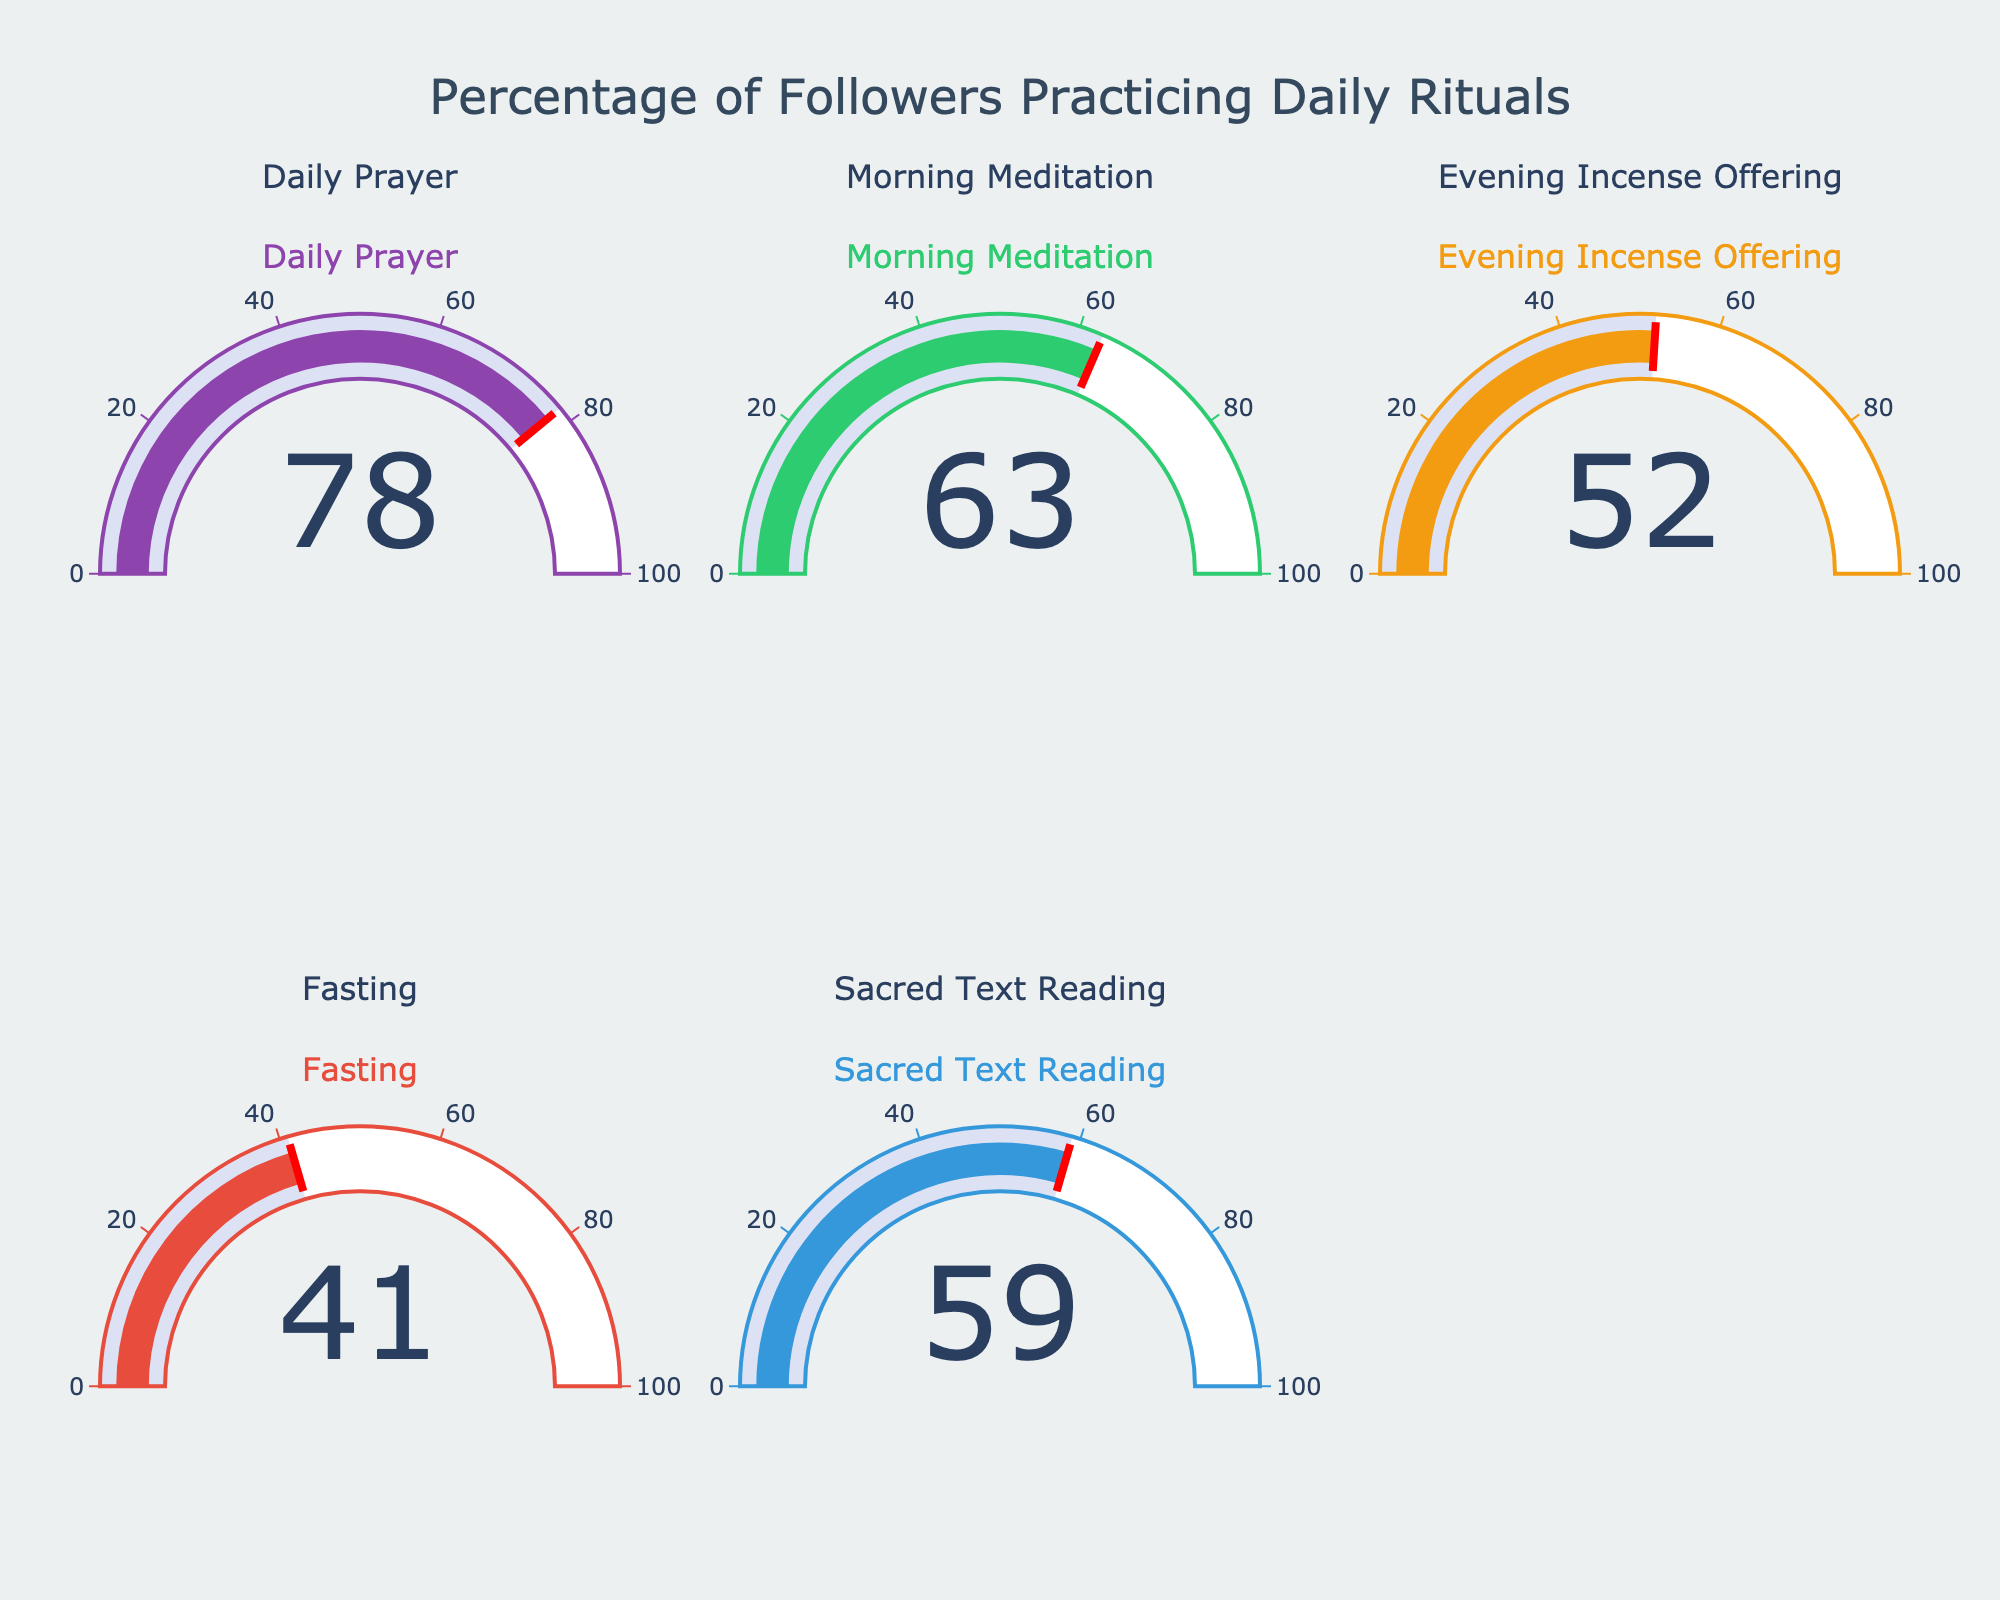What is the percentage of followers practicing daily prayer? The gauge chart for "Daily Prayer" shows a value, which represents the percentage of followers practicing this ritual daily.
Answer: 78% Which ritual has the lowest percentage of followers practicing it daily? Look for the gauge chart with the lowest value among all the rituals displayed.
Answer: Fasting How many rituals have more than 50% of followers practicing them daily? Count the number of gauge charts with values greater than 50%. The values shown are 78%, 63%, 52%, and 59%.
Answer: 4 Which ritual has the highest percentage of followers practicing it daily? Identify the gauge chart with the highest value among all rituals.
Answer: Daily Prayer What is the average percentage of followers practicing Sacred Text Reading and Morning Meditation daily? Add the percentages for "Sacred Text Reading" (59%) and "Morning Meditation" (63%), then divide by 2. (59 + 63)/2 = 122/2
Answer: 61% Compare the percentages between Evening Incense Offering and Fasting, which is higher? Compare the values on the gauge charts for "Evening Incense Offering" (52%) and "Fasting" (41%). Identify which percentage is higher.
Answer: Evening Incense Offering What is the total percentage of followers practicing Evening Incense Offering and Daily Prayer combined? Sum the percentages for "Evening Incense Offering" (52%) and "Daily Prayer" (78%). 52 + 78
Answer: 130% Are there any rituals with exactly the same percentage of followers practicing them daily? Compare all the percentages shown on the gauge charts to check for any identical values. The values are 78%, 63%, 52%, 41%, and 59%.
Answer: No 